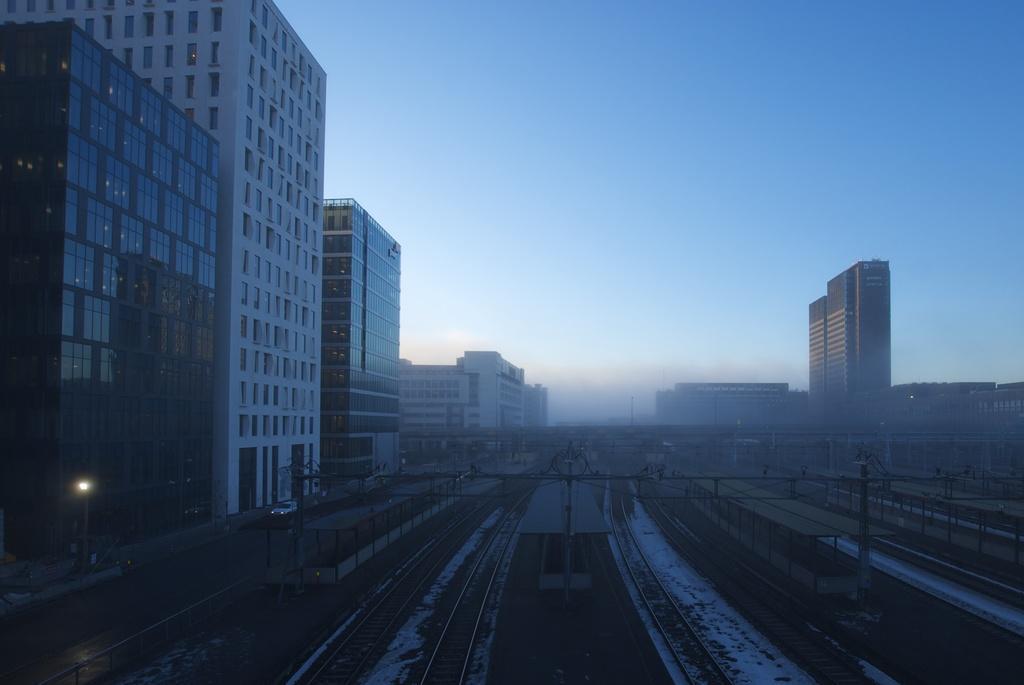Can you describe this image briefly? In this image we can see railway tracks, platforms, poles. buildings, light poles, vehicles moving on the road and the sky in the background. 